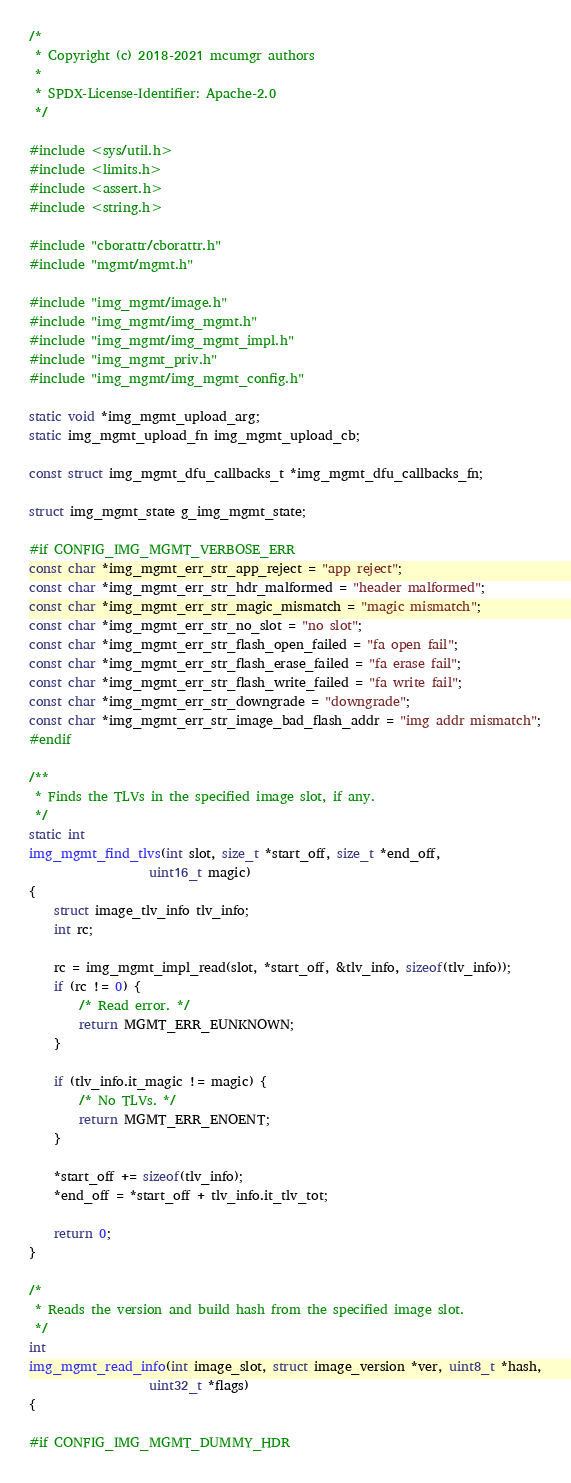<code> <loc_0><loc_0><loc_500><loc_500><_C_>/*
 * Copyright (c) 2018-2021 mcumgr authors
 *
 * SPDX-License-Identifier: Apache-2.0
 */

#include <sys/util.h>
#include <limits.h>
#include <assert.h>
#include <string.h>

#include "cborattr/cborattr.h"
#include "mgmt/mgmt.h"

#include "img_mgmt/image.h"
#include "img_mgmt/img_mgmt.h"
#include "img_mgmt/img_mgmt_impl.h"
#include "img_mgmt_priv.h"
#include "img_mgmt/img_mgmt_config.h"

static void *img_mgmt_upload_arg;
static img_mgmt_upload_fn img_mgmt_upload_cb;

const struct img_mgmt_dfu_callbacks_t *img_mgmt_dfu_callbacks_fn;

struct img_mgmt_state g_img_mgmt_state;

#if CONFIG_IMG_MGMT_VERBOSE_ERR
const char *img_mgmt_err_str_app_reject = "app reject";
const char *img_mgmt_err_str_hdr_malformed = "header malformed";
const char *img_mgmt_err_str_magic_mismatch = "magic mismatch";
const char *img_mgmt_err_str_no_slot = "no slot";
const char *img_mgmt_err_str_flash_open_failed = "fa open fail";
const char *img_mgmt_err_str_flash_erase_failed = "fa erase fail";
const char *img_mgmt_err_str_flash_write_failed = "fa write fail";
const char *img_mgmt_err_str_downgrade = "downgrade";
const char *img_mgmt_err_str_image_bad_flash_addr = "img addr mismatch";
#endif

/**
 * Finds the TLVs in the specified image slot, if any.
 */
static int
img_mgmt_find_tlvs(int slot, size_t *start_off, size_t *end_off,
				   uint16_t magic)
{
	struct image_tlv_info tlv_info;
	int rc;

	rc = img_mgmt_impl_read(slot, *start_off, &tlv_info, sizeof(tlv_info));
	if (rc != 0) {
		/* Read error. */
		return MGMT_ERR_EUNKNOWN;
	}

	if (tlv_info.it_magic != magic) {
		/* No TLVs. */
		return MGMT_ERR_ENOENT;
	}

	*start_off += sizeof(tlv_info);
	*end_off = *start_off + tlv_info.it_tlv_tot;

	return 0;
}

/*
 * Reads the version and build hash from the specified image slot.
 */
int
img_mgmt_read_info(int image_slot, struct image_version *ver, uint8_t *hash,
				   uint32_t *flags)
{

#if CONFIG_IMG_MGMT_DUMMY_HDR</code> 